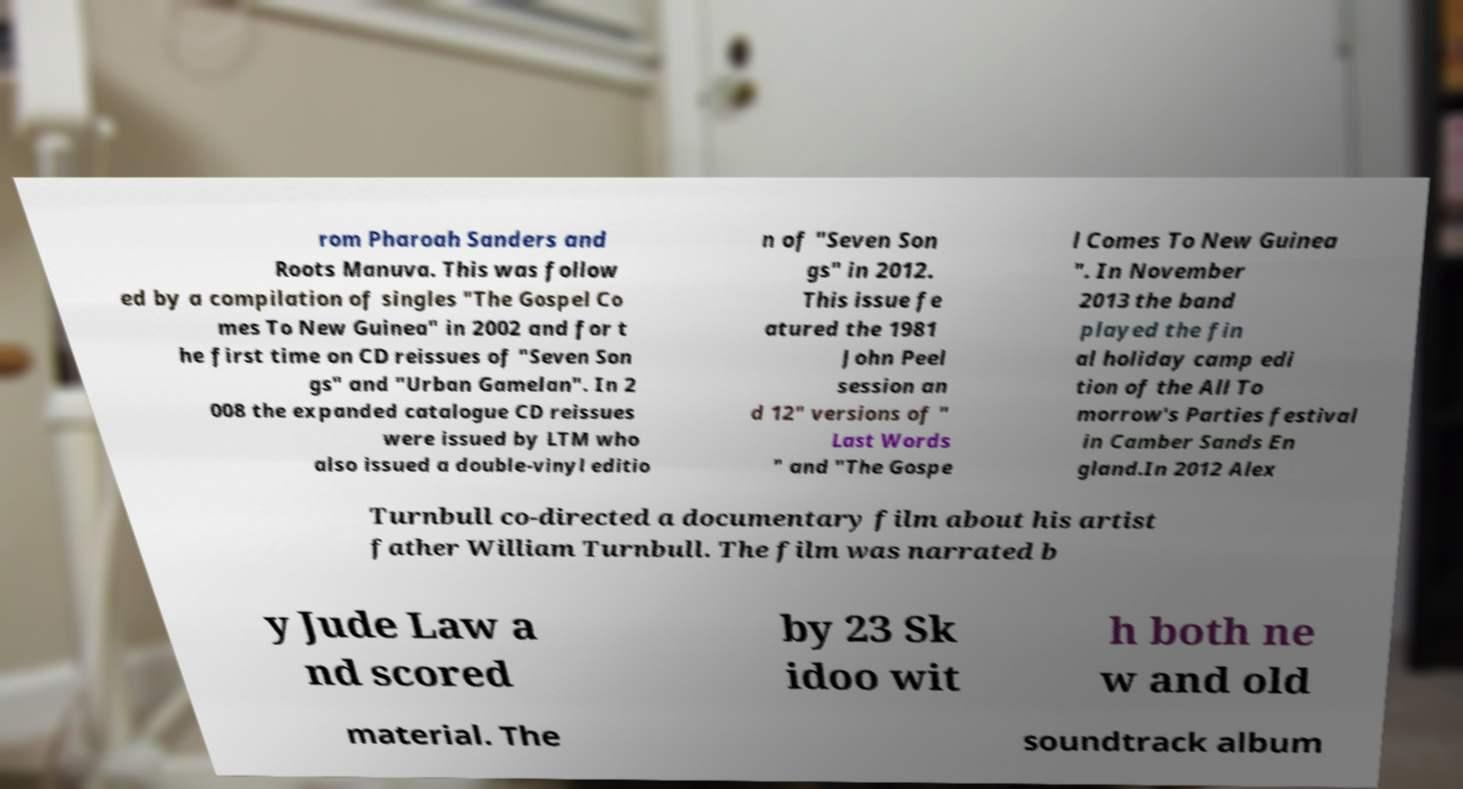Can you accurately transcribe the text from the provided image for me? rom Pharoah Sanders and Roots Manuva. This was follow ed by a compilation of singles "The Gospel Co mes To New Guinea" in 2002 and for t he first time on CD reissues of "Seven Son gs" and "Urban Gamelan". In 2 008 the expanded catalogue CD reissues were issued by LTM who also issued a double-vinyl editio n of "Seven Son gs" in 2012. This issue fe atured the 1981 John Peel session an d 12" versions of " Last Words " and "The Gospe l Comes To New Guinea ". In November 2013 the band played the fin al holiday camp edi tion of the All To morrow's Parties festival in Camber Sands En gland.In 2012 Alex Turnbull co-directed a documentary film about his artist father William Turnbull. The film was narrated b y Jude Law a nd scored by 23 Sk idoo wit h both ne w and old material. The soundtrack album 